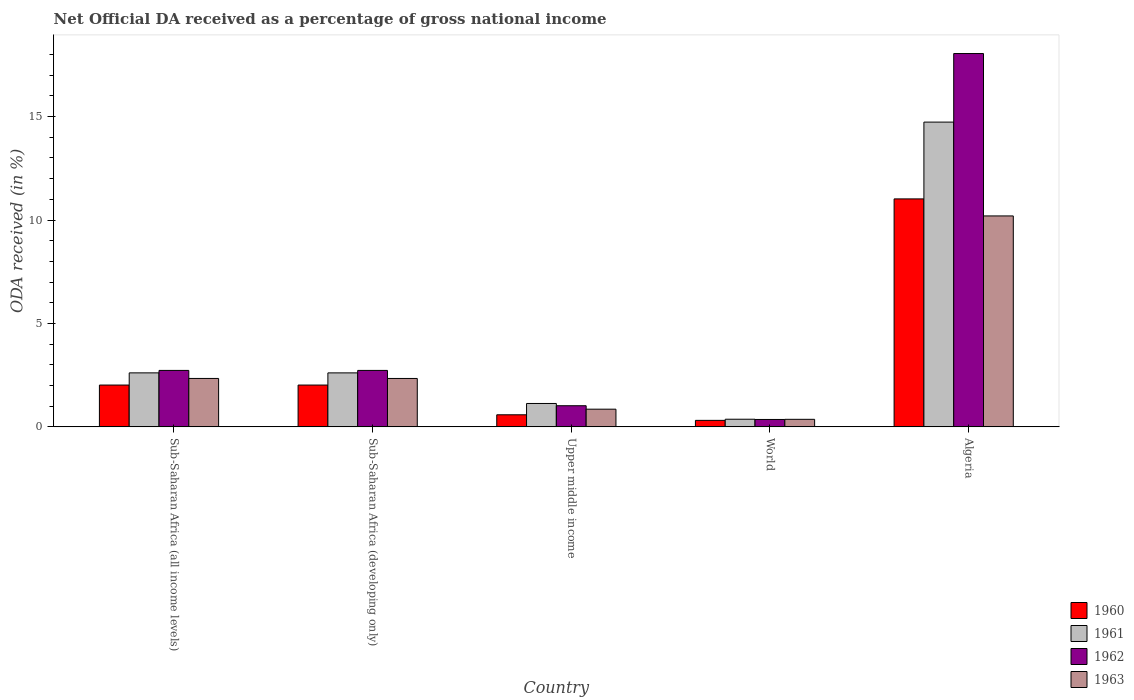Are the number of bars per tick equal to the number of legend labels?
Give a very brief answer. Yes. How many bars are there on the 3rd tick from the right?
Provide a short and direct response. 4. What is the label of the 2nd group of bars from the left?
Your response must be concise. Sub-Saharan Africa (developing only). What is the net official DA received in 1960 in Algeria?
Your response must be concise. 11.02. Across all countries, what is the maximum net official DA received in 1963?
Provide a succinct answer. 10.2. Across all countries, what is the minimum net official DA received in 1960?
Give a very brief answer. 0.31. In which country was the net official DA received in 1962 maximum?
Your response must be concise. Algeria. In which country was the net official DA received in 1960 minimum?
Offer a very short reply. World. What is the total net official DA received in 1960 in the graph?
Give a very brief answer. 15.96. What is the difference between the net official DA received in 1963 in Algeria and that in World?
Provide a short and direct response. 9.83. What is the difference between the net official DA received in 1960 in World and the net official DA received in 1963 in Sub-Saharan Africa (developing only)?
Make the answer very short. -2.03. What is the average net official DA received in 1960 per country?
Your answer should be very brief. 3.19. What is the difference between the net official DA received of/in 1963 and net official DA received of/in 1962 in Sub-Saharan Africa (developing only)?
Provide a short and direct response. -0.39. What is the ratio of the net official DA received in 1960 in Algeria to that in World?
Your response must be concise. 35.04. Is the difference between the net official DA received in 1963 in Algeria and Sub-Saharan Africa (all income levels) greater than the difference between the net official DA received in 1962 in Algeria and Sub-Saharan Africa (all income levels)?
Provide a succinct answer. No. What is the difference between the highest and the second highest net official DA received in 1960?
Ensure brevity in your answer.  -0. What is the difference between the highest and the lowest net official DA received in 1963?
Keep it short and to the point. 9.83. In how many countries, is the net official DA received in 1960 greater than the average net official DA received in 1960 taken over all countries?
Provide a succinct answer. 1. Is the sum of the net official DA received in 1961 in Sub-Saharan Africa (developing only) and Upper middle income greater than the maximum net official DA received in 1963 across all countries?
Your response must be concise. No. Is it the case that in every country, the sum of the net official DA received in 1963 and net official DA received in 1960 is greater than the sum of net official DA received in 1961 and net official DA received in 1962?
Offer a terse response. No. What does the 4th bar from the left in Sub-Saharan Africa (developing only) represents?
Offer a very short reply. 1963. Is it the case that in every country, the sum of the net official DA received in 1962 and net official DA received in 1960 is greater than the net official DA received in 1963?
Ensure brevity in your answer.  Yes. How many countries are there in the graph?
Your answer should be compact. 5. What is the difference between two consecutive major ticks on the Y-axis?
Your answer should be very brief. 5. How are the legend labels stacked?
Keep it short and to the point. Vertical. What is the title of the graph?
Offer a very short reply. Net Official DA received as a percentage of gross national income. Does "1960" appear as one of the legend labels in the graph?
Your answer should be very brief. Yes. What is the label or title of the Y-axis?
Keep it short and to the point. ODA received (in %). What is the ODA received (in %) of 1960 in Sub-Saharan Africa (all income levels)?
Ensure brevity in your answer.  2.02. What is the ODA received (in %) of 1961 in Sub-Saharan Africa (all income levels)?
Your answer should be compact. 2.61. What is the ODA received (in %) in 1962 in Sub-Saharan Africa (all income levels)?
Your answer should be very brief. 2.73. What is the ODA received (in %) of 1963 in Sub-Saharan Africa (all income levels)?
Keep it short and to the point. 2.34. What is the ODA received (in %) in 1960 in Sub-Saharan Africa (developing only)?
Provide a succinct answer. 2.02. What is the ODA received (in %) in 1961 in Sub-Saharan Africa (developing only)?
Offer a terse response. 2.61. What is the ODA received (in %) of 1962 in Sub-Saharan Africa (developing only)?
Provide a succinct answer. 2.73. What is the ODA received (in %) in 1963 in Sub-Saharan Africa (developing only)?
Your response must be concise. 2.34. What is the ODA received (in %) of 1960 in Upper middle income?
Make the answer very short. 0.58. What is the ODA received (in %) in 1961 in Upper middle income?
Offer a terse response. 1.13. What is the ODA received (in %) in 1962 in Upper middle income?
Your answer should be compact. 1.02. What is the ODA received (in %) in 1963 in Upper middle income?
Ensure brevity in your answer.  0.86. What is the ODA received (in %) in 1960 in World?
Your response must be concise. 0.31. What is the ODA received (in %) of 1961 in World?
Keep it short and to the point. 0.37. What is the ODA received (in %) of 1962 in World?
Your answer should be compact. 0.36. What is the ODA received (in %) in 1963 in World?
Offer a very short reply. 0.36. What is the ODA received (in %) of 1960 in Algeria?
Make the answer very short. 11.02. What is the ODA received (in %) of 1961 in Algeria?
Your answer should be very brief. 14.73. What is the ODA received (in %) of 1962 in Algeria?
Keep it short and to the point. 18.05. What is the ODA received (in %) in 1963 in Algeria?
Your answer should be compact. 10.2. Across all countries, what is the maximum ODA received (in %) of 1960?
Your answer should be very brief. 11.02. Across all countries, what is the maximum ODA received (in %) in 1961?
Offer a very short reply. 14.73. Across all countries, what is the maximum ODA received (in %) in 1962?
Give a very brief answer. 18.05. Across all countries, what is the maximum ODA received (in %) in 1963?
Offer a very short reply. 10.2. Across all countries, what is the minimum ODA received (in %) of 1960?
Give a very brief answer. 0.31. Across all countries, what is the minimum ODA received (in %) in 1961?
Provide a succinct answer. 0.37. Across all countries, what is the minimum ODA received (in %) in 1962?
Give a very brief answer. 0.36. Across all countries, what is the minimum ODA received (in %) in 1963?
Provide a succinct answer. 0.36. What is the total ODA received (in %) of 1960 in the graph?
Ensure brevity in your answer.  15.96. What is the total ODA received (in %) in 1961 in the graph?
Ensure brevity in your answer.  21.46. What is the total ODA received (in %) of 1962 in the graph?
Offer a very short reply. 24.89. What is the total ODA received (in %) of 1963 in the graph?
Ensure brevity in your answer.  16.1. What is the difference between the ODA received (in %) in 1961 in Sub-Saharan Africa (all income levels) and that in Sub-Saharan Africa (developing only)?
Ensure brevity in your answer.  0. What is the difference between the ODA received (in %) of 1962 in Sub-Saharan Africa (all income levels) and that in Sub-Saharan Africa (developing only)?
Your answer should be very brief. 0. What is the difference between the ODA received (in %) in 1963 in Sub-Saharan Africa (all income levels) and that in Sub-Saharan Africa (developing only)?
Your answer should be compact. 0. What is the difference between the ODA received (in %) of 1960 in Sub-Saharan Africa (all income levels) and that in Upper middle income?
Offer a very short reply. 1.44. What is the difference between the ODA received (in %) in 1961 in Sub-Saharan Africa (all income levels) and that in Upper middle income?
Your response must be concise. 1.48. What is the difference between the ODA received (in %) of 1962 in Sub-Saharan Africa (all income levels) and that in Upper middle income?
Your answer should be very brief. 1.71. What is the difference between the ODA received (in %) of 1963 in Sub-Saharan Africa (all income levels) and that in Upper middle income?
Your answer should be compact. 1.49. What is the difference between the ODA received (in %) of 1960 in Sub-Saharan Africa (all income levels) and that in World?
Make the answer very short. 1.71. What is the difference between the ODA received (in %) in 1961 in Sub-Saharan Africa (all income levels) and that in World?
Offer a terse response. 2.24. What is the difference between the ODA received (in %) of 1962 in Sub-Saharan Africa (all income levels) and that in World?
Keep it short and to the point. 2.37. What is the difference between the ODA received (in %) of 1963 in Sub-Saharan Africa (all income levels) and that in World?
Provide a succinct answer. 1.98. What is the difference between the ODA received (in %) in 1960 in Sub-Saharan Africa (all income levels) and that in Algeria?
Provide a succinct answer. -9. What is the difference between the ODA received (in %) of 1961 in Sub-Saharan Africa (all income levels) and that in Algeria?
Give a very brief answer. -12.12. What is the difference between the ODA received (in %) in 1962 in Sub-Saharan Africa (all income levels) and that in Algeria?
Your response must be concise. -15.32. What is the difference between the ODA received (in %) in 1963 in Sub-Saharan Africa (all income levels) and that in Algeria?
Your answer should be compact. -7.86. What is the difference between the ODA received (in %) in 1960 in Sub-Saharan Africa (developing only) and that in Upper middle income?
Provide a succinct answer. 1.44. What is the difference between the ODA received (in %) in 1961 in Sub-Saharan Africa (developing only) and that in Upper middle income?
Make the answer very short. 1.48. What is the difference between the ODA received (in %) in 1962 in Sub-Saharan Africa (developing only) and that in Upper middle income?
Give a very brief answer. 1.71. What is the difference between the ODA received (in %) in 1963 in Sub-Saharan Africa (developing only) and that in Upper middle income?
Keep it short and to the point. 1.49. What is the difference between the ODA received (in %) of 1960 in Sub-Saharan Africa (developing only) and that in World?
Make the answer very short. 1.71. What is the difference between the ODA received (in %) in 1961 in Sub-Saharan Africa (developing only) and that in World?
Offer a very short reply. 2.24. What is the difference between the ODA received (in %) of 1962 in Sub-Saharan Africa (developing only) and that in World?
Your response must be concise. 2.37. What is the difference between the ODA received (in %) of 1963 in Sub-Saharan Africa (developing only) and that in World?
Your answer should be very brief. 1.98. What is the difference between the ODA received (in %) of 1960 in Sub-Saharan Africa (developing only) and that in Algeria?
Give a very brief answer. -9. What is the difference between the ODA received (in %) of 1961 in Sub-Saharan Africa (developing only) and that in Algeria?
Provide a succinct answer. -12.12. What is the difference between the ODA received (in %) of 1962 in Sub-Saharan Africa (developing only) and that in Algeria?
Give a very brief answer. -15.32. What is the difference between the ODA received (in %) in 1963 in Sub-Saharan Africa (developing only) and that in Algeria?
Provide a short and direct response. -7.86. What is the difference between the ODA received (in %) in 1960 in Upper middle income and that in World?
Your response must be concise. 0.27. What is the difference between the ODA received (in %) of 1961 in Upper middle income and that in World?
Ensure brevity in your answer.  0.76. What is the difference between the ODA received (in %) of 1962 in Upper middle income and that in World?
Make the answer very short. 0.66. What is the difference between the ODA received (in %) in 1963 in Upper middle income and that in World?
Your response must be concise. 0.49. What is the difference between the ODA received (in %) in 1960 in Upper middle income and that in Algeria?
Make the answer very short. -10.44. What is the difference between the ODA received (in %) in 1961 in Upper middle income and that in Algeria?
Keep it short and to the point. -13.6. What is the difference between the ODA received (in %) of 1962 in Upper middle income and that in Algeria?
Your answer should be compact. -17.03. What is the difference between the ODA received (in %) of 1963 in Upper middle income and that in Algeria?
Ensure brevity in your answer.  -9.34. What is the difference between the ODA received (in %) in 1960 in World and that in Algeria?
Your response must be concise. -10.71. What is the difference between the ODA received (in %) in 1961 in World and that in Algeria?
Offer a very short reply. -14.36. What is the difference between the ODA received (in %) in 1962 in World and that in Algeria?
Provide a succinct answer. -17.69. What is the difference between the ODA received (in %) of 1963 in World and that in Algeria?
Offer a very short reply. -9.83. What is the difference between the ODA received (in %) in 1960 in Sub-Saharan Africa (all income levels) and the ODA received (in %) in 1961 in Sub-Saharan Africa (developing only)?
Give a very brief answer. -0.59. What is the difference between the ODA received (in %) in 1960 in Sub-Saharan Africa (all income levels) and the ODA received (in %) in 1962 in Sub-Saharan Africa (developing only)?
Offer a very short reply. -0.71. What is the difference between the ODA received (in %) in 1960 in Sub-Saharan Africa (all income levels) and the ODA received (in %) in 1963 in Sub-Saharan Africa (developing only)?
Your response must be concise. -0.32. What is the difference between the ODA received (in %) in 1961 in Sub-Saharan Africa (all income levels) and the ODA received (in %) in 1962 in Sub-Saharan Africa (developing only)?
Your answer should be very brief. -0.12. What is the difference between the ODA received (in %) of 1961 in Sub-Saharan Africa (all income levels) and the ODA received (in %) of 1963 in Sub-Saharan Africa (developing only)?
Provide a succinct answer. 0.27. What is the difference between the ODA received (in %) of 1962 in Sub-Saharan Africa (all income levels) and the ODA received (in %) of 1963 in Sub-Saharan Africa (developing only)?
Your answer should be compact. 0.39. What is the difference between the ODA received (in %) in 1960 in Sub-Saharan Africa (all income levels) and the ODA received (in %) in 1961 in Upper middle income?
Your answer should be very brief. 0.89. What is the difference between the ODA received (in %) in 1960 in Sub-Saharan Africa (all income levels) and the ODA received (in %) in 1962 in Upper middle income?
Offer a very short reply. 1. What is the difference between the ODA received (in %) of 1960 in Sub-Saharan Africa (all income levels) and the ODA received (in %) of 1963 in Upper middle income?
Your answer should be very brief. 1.17. What is the difference between the ODA received (in %) in 1961 in Sub-Saharan Africa (all income levels) and the ODA received (in %) in 1962 in Upper middle income?
Your answer should be compact. 1.59. What is the difference between the ODA received (in %) of 1961 in Sub-Saharan Africa (all income levels) and the ODA received (in %) of 1963 in Upper middle income?
Your answer should be very brief. 1.76. What is the difference between the ODA received (in %) of 1962 in Sub-Saharan Africa (all income levels) and the ODA received (in %) of 1963 in Upper middle income?
Keep it short and to the point. 1.87. What is the difference between the ODA received (in %) in 1960 in Sub-Saharan Africa (all income levels) and the ODA received (in %) in 1961 in World?
Your answer should be very brief. 1.65. What is the difference between the ODA received (in %) in 1960 in Sub-Saharan Africa (all income levels) and the ODA received (in %) in 1962 in World?
Keep it short and to the point. 1.66. What is the difference between the ODA received (in %) in 1960 in Sub-Saharan Africa (all income levels) and the ODA received (in %) in 1963 in World?
Your response must be concise. 1.66. What is the difference between the ODA received (in %) of 1961 in Sub-Saharan Africa (all income levels) and the ODA received (in %) of 1962 in World?
Provide a succinct answer. 2.25. What is the difference between the ODA received (in %) of 1961 in Sub-Saharan Africa (all income levels) and the ODA received (in %) of 1963 in World?
Keep it short and to the point. 2.25. What is the difference between the ODA received (in %) in 1962 in Sub-Saharan Africa (all income levels) and the ODA received (in %) in 1963 in World?
Keep it short and to the point. 2.37. What is the difference between the ODA received (in %) of 1960 in Sub-Saharan Africa (all income levels) and the ODA received (in %) of 1961 in Algeria?
Make the answer very short. -12.71. What is the difference between the ODA received (in %) in 1960 in Sub-Saharan Africa (all income levels) and the ODA received (in %) in 1962 in Algeria?
Offer a very short reply. -16.03. What is the difference between the ODA received (in %) in 1960 in Sub-Saharan Africa (all income levels) and the ODA received (in %) in 1963 in Algeria?
Your response must be concise. -8.18. What is the difference between the ODA received (in %) in 1961 in Sub-Saharan Africa (all income levels) and the ODA received (in %) in 1962 in Algeria?
Ensure brevity in your answer.  -15.44. What is the difference between the ODA received (in %) in 1961 in Sub-Saharan Africa (all income levels) and the ODA received (in %) in 1963 in Algeria?
Ensure brevity in your answer.  -7.59. What is the difference between the ODA received (in %) of 1962 in Sub-Saharan Africa (all income levels) and the ODA received (in %) of 1963 in Algeria?
Give a very brief answer. -7.47. What is the difference between the ODA received (in %) of 1960 in Sub-Saharan Africa (developing only) and the ODA received (in %) of 1961 in Upper middle income?
Give a very brief answer. 0.89. What is the difference between the ODA received (in %) in 1960 in Sub-Saharan Africa (developing only) and the ODA received (in %) in 1962 in Upper middle income?
Your answer should be compact. 1. What is the difference between the ODA received (in %) of 1960 in Sub-Saharan Africa (developing only) and the ODA received (in %) of 1963 in Upper middle income?
Give a very brief answer. 1.17. What is the difference between the ODA received (in %) of 1961 in Sub-Saharan Africa (developing only) and the ODA received (in %) of 1962 in Upper middle income?
Ensure brevity in your answer.  1.59. What is the difference between the ODA received (in %) of 1961 in Sub-Saharan Africa (developing only) and the ODA received (in %) of 1963 in Upper middle income?
Make the answer very short. 1.75. What is the difference between the ODA received (in %) in 1962 in Sub-Saharan Africa (developing only) and the ODA received (in %) in 1963 in Upper middle income?
Keep it short and to the point. 1.87. What is the difference between the ODA received (in %) of 1960 in Sub-Saharan Africa (developing only) and the ODA received (in %) of 1961 in World?
Offer a terse response. 1.65. What is the difference between the ODA received (in %) of 1960 in Sub-Saharan Africa (developing only) and the ODA received (in %) of 1962 in World?
Offer a very short reply. 1.66. What is the difference between the ODA received (in %) in 1960 in Sub-Saharan Africa (developing only) and the ODA received (in %) in 1963 in World?
Your response must be concise. 1.66. What is the difference between the ODA received (in %) in 1961 in Sub-Saharan Africa (developing only) and the ODA received (in %) in 1962 in World?
Your answer should be very brief. 2.25. What is the difference between the ODA received (in %) of 1961 in Sub-Saharan Africa (developing only) and the ODA received (in %) of 1963 in World?
Your answer should be very brief. 2.25. What is the difference between the ODA received (in %) of 1962 in Sub-Saharan Africa (developing only) and the ODA received (in %) of 1963 in World?
Your answer should be very brief. 2.36. What is the difference between the ODA received (in %) in 1960 in Sub-Saharan Africa (developing only) and the ODA received (in %) in 1961 in Algeria?
Your answer should be very brief. -12.71. What is the difference between the ODA received (in %) of 1960 in Sub-Saharan Africa (developing only) and the ODA received (in %) of 1962 in Algeria?
Your answer should be very brief. -16.03. What is the difference between the ODA received (in %) of 1960 in Sub-Saharan Africa (developing only) and the ODA received (in %) of 1963 in Algeria?
Give a very brief answer. -8.18. What is the difference between the ODA received (in %) of 1961 in Sub-Saharan Africa (developing only) and the ODA received (in %) of 1962 in Algeria?
Offer a very short reply. -15.44. What is the difference between the ODA received (in %) of 1961 in Sub-Saharan Africa (developing only) and the ODA received (in %) of 1963 in Algeria?
Provide a short and direct response. -7.59. What is the difference between the ODA received (in %) of 1962 in Sub-Saharan Africa (developing only) and the ODA received (in %) of 1963 in Algeria?
Make the answer very short. -7.47. What is the difference between the ODA received (in %) of 1960 in Upper middle income and the ODA received (in %) of 1961 in World?
Provide a succinct answer. 0.21. What is the difference between the ODA received (in %) in 1960 in Upper middle income and the ODA received (in %) in 1962 in World?
Ensure brevity in your answer.  0.23. What is the difference between the ODA received (in %) in 1960 in Upper middle income and the ODA received (in %) in 1963 in World?
Offer a very short reply. 0.22. What is the difference between the ODA received (in %) in 1961 in Upper middle income and the ODA received (in %) in 1962 in World?
Your answer should be very brief. 0.77. What is the difference between the ODA received (in %) of 1961 in Upper middle income and the ODA received (in %) of 1963 in World?
Give a very brief answer. 0.77. What is the difference between the ODA received (in %) in 1962 in Upper middle income and the ODA received (in %) in 1963 in World?
Give a very brief answer. 0.66. What is the difference between the ODA received (in %) of 1960 in Upper middle income and the ODA received (in %) of 1961 in Algeria?
Keep it short and to the point. -14.15. What is the difference between the ODA received (in %) of 1960 in Upper middle income and the ODA received (in %) of 1962 in Algeria?
Give a very brief answer. -17.46. What is the difference between the ODA received (in %) of 1960 in Upper middle income and the ODA received (in %) of 1963 in Algeria?
Provide a short and direct response. -9.61. What is the difference between the ODA received (in %) in 1961 in Upper middle income and the ODA received (in %) in 1962 in Algeria?
Offer a very short reply. -16.92. What is the difference between the ODA received (in %) of 1961 in Upper middle income and the ODA received (in %) of 1963 in Algeria?
Your answer should be very brief. -9.07. What is the difference between the ODA received (in %) of 1962 in Upper middle income and the ODA received (in %) of 1963 in Algeria?
Your answer should be compact. -9.18. What is the difference between the ODA received (in %) in 1960 in World and the ODA received (in %) in 1961 in Algeria?
Your answer should be compact. -14.42. What is the difference between the ODA received (in %) of 1960 in World and the ODA received (in %) of 1962 in Algeria?
Offer a terse response. -17.73. What is the difference between the ODA received (in %) of 1960 in World and the ODA received (in %) of 1963 in Algeria?
Offer a terse response. -9.88. What is the difference between the ODA received (in %) in 1961 in World and the ODA received (in %) in 1962 in Algeria?
Provide a succinct answer. -17.68. What is the difference between the ODA received (in %) in 1961 in World and the ODA received (in %) in 1963 in Algeria?
Provide a short and direct response. -9.83. What is the difference between the ODA received (in %) in 1962 in World and the ODA received (in %) in 1963 in Algeria?
Your answer should be compact. -9.84. What is the average ODA received (in %) of 1960 per country?
Your answer should be very brief. 3.19. What is the average ODA received (in %) in 1961 per country?
Provide a short and direct response. 4.29. What is the average ODA received (in %) in 1962 per country?
Give a very brief answer. 4.98. What is the average ODA received (in %) of 1963 per country?
Provide a short and direct response. 3.22. What is the difference between the ODA received (in %) of 1960 and ODA received (in %) of 1961 in Sub-Saharan Africa (all income levels)?
Offer a terse response. -0.59. What is the difference between the ODA received (in %) in 1960 and ODA received (in %) in 1962 in Sub-Saharan Africa (all income levels)?
Ensure brevity in your answer.  -0.71. What is the difference between the ODA received (in %) in 1960 and ODA received (in %) in 1963 in Sub-Saharan Africa (all income levels)?
Make the answer very short. -0.32. What is the difference between the ODA received (in %) of 1961 and ODA received (in %) of 1962 in Sub-Saharan Africa (all income levels)?
Your response must be concise. -0.12. What is the difference between the ODA received (in %) in 1961 and ODA received (in %) in 1963 in Sub-Saharan Africa (all income levels)?
Your answer should be compact. 0.27. What is the difference between the ODA received (in %) in 1962 and ODA received (in %) in 1963 in Sub-Saharan Africa (all income levels)?
Make the answer very short. 0.39. What is the difference between the ODA received (in %) of 1960 and ODA received (in %) of 1961 in Sub-Saharan Africa (developing only)?
Make the answer very short. -0.59. What is the difference between the ODA received (in %) in 1960 and ODA received (in %) in 1962 in Sub-Saharan Africa (developing only)?
Provide a succinct answer. -0.71. What is the difference between the ODA received (in %) of 1960 and ODA received (in %) of 1963 in Sub-Saharan Africa (developing only)?
Your response must be concise. -0.32. What is the difference between the ODA received (in %) in 1961 and ODA received (in %) in 1962 in Sub-Saharan Africa (developing only)?
Provide a succinct answer. -0.12. What is the difference between the ODA received (in %) of 1961 and ODA received (in %) of 1963 in Sub-Saharan Africa (developing only)?
Your answer should be compact. 0.27. What is the difference between the ODA received (in %) in 1962 and ODA received (in %) in 1963 in Sub-Saharan Africa (developing only)?
Your answer should be very brief. 0.39. What is the difference between the ODA received (in %) in 1960 and ODA received (in %) in 1961 in Upper middle income?
Offer a terse response. -0.55. What is the difference between the ODA received (in %) in 1960 and ODA received (in %) in 1962 in Upper middle income?
Offer a terse response. -0.44. What is the difference between the ODA received (in %) in 1960 and ODA received (in %) in 1963 in Upper middle income?
Your response must be concise. -0.27. What is the difference between the ODA received (in %) of 1961 and ODA received (in %) of 1962 in Upper middle income?
Offer a very short reply. 0.11. What is the difference between the ODA received (in %) in 1961 and ODA received (in %) in 1963 in Upper middle income?
Offer a very short reply. 0.28. What is the difference between the ODA received (in %) in 1962 and ODA received (in %) in 1963 in Upper middle income?
Make the answer very short. 0.17. What is the difference between the ODA received (in %) in 1960 and ODA received (in %) in 1961 in World?
Ensure brevity in your answer.  -0.06. What is the difference between the ODA received (in %) of 1960 and ODA received (in %) of 1962 in World?
Keep it short and to the point. -0.04. What is the difference between the ODA received (in %) in 1960 and ODA received (in %) in 1963 in World?
Give a very brief answer. -0.05. What is the difference between the ODA received (in %) of 1961 and ODA received (in %) of 1962 in World?
Ensure brevity in your answer.  0.01. What is the difference between the ODA received (in %) in 1961 and ODA received (in %) in 1963 in World?
Keep it short and to the point. 0. What is the difference between the ODA received (in %) in 1962 and ODA received (in %) in 1963 in World?
Keep it short and to the point. -0.01. What is the difference between the ODA received (in %) in 1960 and ODA received (in %) in 1961 in Algeria?
Ensure brevity in your answer.  -3.71. What is the difference between the ODA received (in %) in 1960 and ODA received (in %) in 1962 in Algeria?
Provide a succinct answer. -7.03. What is the difference between the ODA received (in %) of 1960 and ODA received (in %) of 1963 in Algeria?
Offer a terse response. 0.82. What is the difference between the ODA received (in %) of 1961 and ODA received (in %) of 1962 in Algeria?
Offer a very short reply. -3.31. What is the difference between the ODA received (in %) of 1961 and ODA received (in %) of 1963 in Algeria?
Make the answer very short. 4.54. What is the difference between the ODA received (in %) in 1962 and ODA received (in %) in 1963 in Algeria?
Ensure brevity in your answer.  7.85. What is the ratio of the ODA received (in %) of 1960 in Sub-Saharan Africa (all income levels) to that in Sub-Saharan Africa (developing only)?
Ensure brevity in your answer.  1. What is the ratio of the ODA received (in %) in 1960 in Sub-Saharan Africa (all income levels) to that in Upper middle income?
Provide a short and direct response. 3.46. What is the ratio of the ODA received (in %) of 1961 in Sub-Saharan Africa (all income levels) to that in Upper middle income?
Your answer should be very brief. 2.31. What is the ratio of the ODA received (in %) of 1962 in Sub-Saharan Africa (all income levels) to that in Upper middle income?
Provide a succinct answer. 2.67. What is the ratio of the ODA received (in %) in 1963 in Sub-Saharan Africa (all income levels) to that in Upper middle income?
Your answer should be very brief. 2.74. What is the ratio of the ODA received (in %) in 1960 in Sub-Saharan Africa (all income levels) to that in World?
Offer a terse response. 6.43. What is the ratio of the ODA received (in %) of 1961 in Sub-Saharan Africa (all income levels) to that in World?
Your answer should be very brief. 7.07. What is the ratio of the ODA received (in %) of 1962 in Sub-Saharan Africa (all income levels) to that in World?
Your response must be concise. 7.62. What is the ratio of the ODA received (in %) in 1963 in Sub-Saharan Africa (all income levels) to that in World?
Your answer should be compact. 6.42. What is the ratio of the ODA received (in %) in 1960 in Sub-Saharan Africa (all income levels) to that in Algeria?
Provide a short and direct response. 0.18. What is the ratio of the ODA received (in %) in 1961 in Sub-Saharan Africa (all income levels) to that in Algeria?
Offer a terse response. 0.18. What is the ratio of the ODA received (in %) of 1962 in Sub-Saharan Africa (all income levels) to that in Algeria?
Your answer should be compact. 0.15. What is the ratio of the ODA received (in %) of 1963 in Sub-Saharan Africa (all income levels) to that in Algeria?
Offer a terse response. 0.23. What is the ratio of the ODA received (in %) in 1960 in Sub-Saharan Africa (developing only) to that in Upper middle income?
Offer a very short reply. 3.46. What is the ratio of the ODA received (in %) of 1961 in Sub-Saharan Africa (developing only) to that in Upper middle income?
Provide a succinct answer. 2.31. What is the ratio of the ODA received (in %) of 1962 in Sub-Saharan Africa (developing only) to that in Upper middle income?
Your answer should be very brief. 2.67. What is the ratio of the ODA received (in %) of 1963 in Sub-Saharan Africa (developing only) to that in Upper middle income?
Offer a terse response. 2.74. What is the ratio of the ODA received (in %) in 1960 in Sub-Saharan Africa (developing only) to that in World?
Offer a terse response. 6.43. What is the ratio of the ODA received (in %) of 1961 in Sub-Saharan Africa (developing only) to that in World?
Keep it short and to the point. 7.06. What is the ratio of the ODA received (in %) in 1962 in Sub-Saharan Africa (developing only) to that in World?
Give a very brief answer. 7.62. What is the ratio of the ODA received (in %) of 1963 in Sub-Saharan Africa (developing only) to that in World?
Offer a very short reply. 6.42. What is the ratio of the ODA received (in %) in 1960 in Sub-Saharan Africa (developing only) to that in Algeria?
Offer a very short reply. 0.18. What is the ratio of the ODA received (in %) in 1961 in Sub-Saharan Africa (developing only) to that in Algeria?
Make the answer very short. 0.18. What is the ratio of the ODA received (in %) of 1962 in Sub-Saharan Africa (developing only) to that in Algeria?
Your answer should be very brief. 0.15. What is the ratio of the ODA received (in %) in 1963 in Sub-Saharan Africa (developing only) to that in Algeria?
Ensure brevity in your answer.  0.23. What is the ratio of the ODA received (in %) in 1960 in Upper middle income to that in World?
Ensure brevity in your answer.  1.86. What is the ratio of the ODA received (in %) in 1961 in Upper middle income to that in World?
Your answer should be compact. 3.06. What is the ratio of the ODA received (in %) in 1962 in Upper middle income to that in World?
Your response must be concise. 2.85. What is the ratio of the ODA received (in %) in 1963 in Upper middle income to that in World?
Provide a short and direct response. 2.34. What is the ratio of the ODA received (in %) in 1960 in Upper middle income to that in Algeria?
Your answer should be compact. 0.05. What is the ratio of the ODA received (in %) of 1961 in Upper middle income to that in Algeria?
Your answer should be compact. 0.08. What is the ratio of the ODA received (in %) in 1962 in Upper middle income to that in Algeria?
Offer a very short reply. 0.06. What is the ratio of the ODA received (in %) of 1963 in Upper middle income to that in Algeria?
Provide a short and direct response. 0.08. What is the ratio of the ODA received (in %) in 1960 in World to that in Algeria?
Offer a very short reply. 0.03. What is the ratio of the ODA received (in %) in 1961 in World to that in Algeria?
Your answer should be very brief. 0.03. What is the ratio of the ODA received (in %) of 1962 in World to that in Algeria?
Ensure brevity in your answer.  0.02. What is the ratio of the ODA received (in %) of 1963 in World to that in Algeria?
Offer a very short reply. 0.04. What is the difference between the highest and the second highest ODA received (in %) in 1960?
Your answer should be compact. 9. What is the difference between the highest and the second highest ODA received (in %) of 1961?
Make the answer very short. 12.12. What is the difference between the highest and the second highest ODA received (in %) in 1962?
Your answer should be compact. 15.32. What is the difference between the highest and the second highest ODA received (in %) of 1963?
Keep it short and to the point. 7.86. What is the difference between the highest and the lowest ODA received (in %) in 1960?
Provide a succinct answer. 10.71. What is the difference between the highest and the lowest ODA received (in %) in 1961?
Ensure brevity in your answer.  14.36. What is the difference between the highest and the lowest ODA received (in %) in 1962?
Make the answer very short. 17.69. What is the difference between the highest and the lowest ODA received (in %) of 1963?
Your response must be concise. 9.83. 